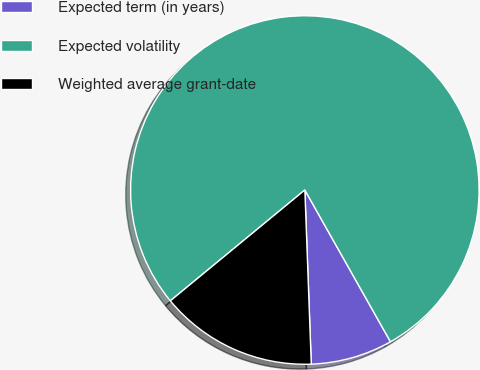<chart> <loc_0><loc_0><loc_500><loc_500><pie_chart><fcel>Expected term (in years)<fcel>Expected volatility<fcel>Weighted average grant-date<nl><fcel>7.59%<fcel>77.79%<fcel>14.62%<nl></chart> 